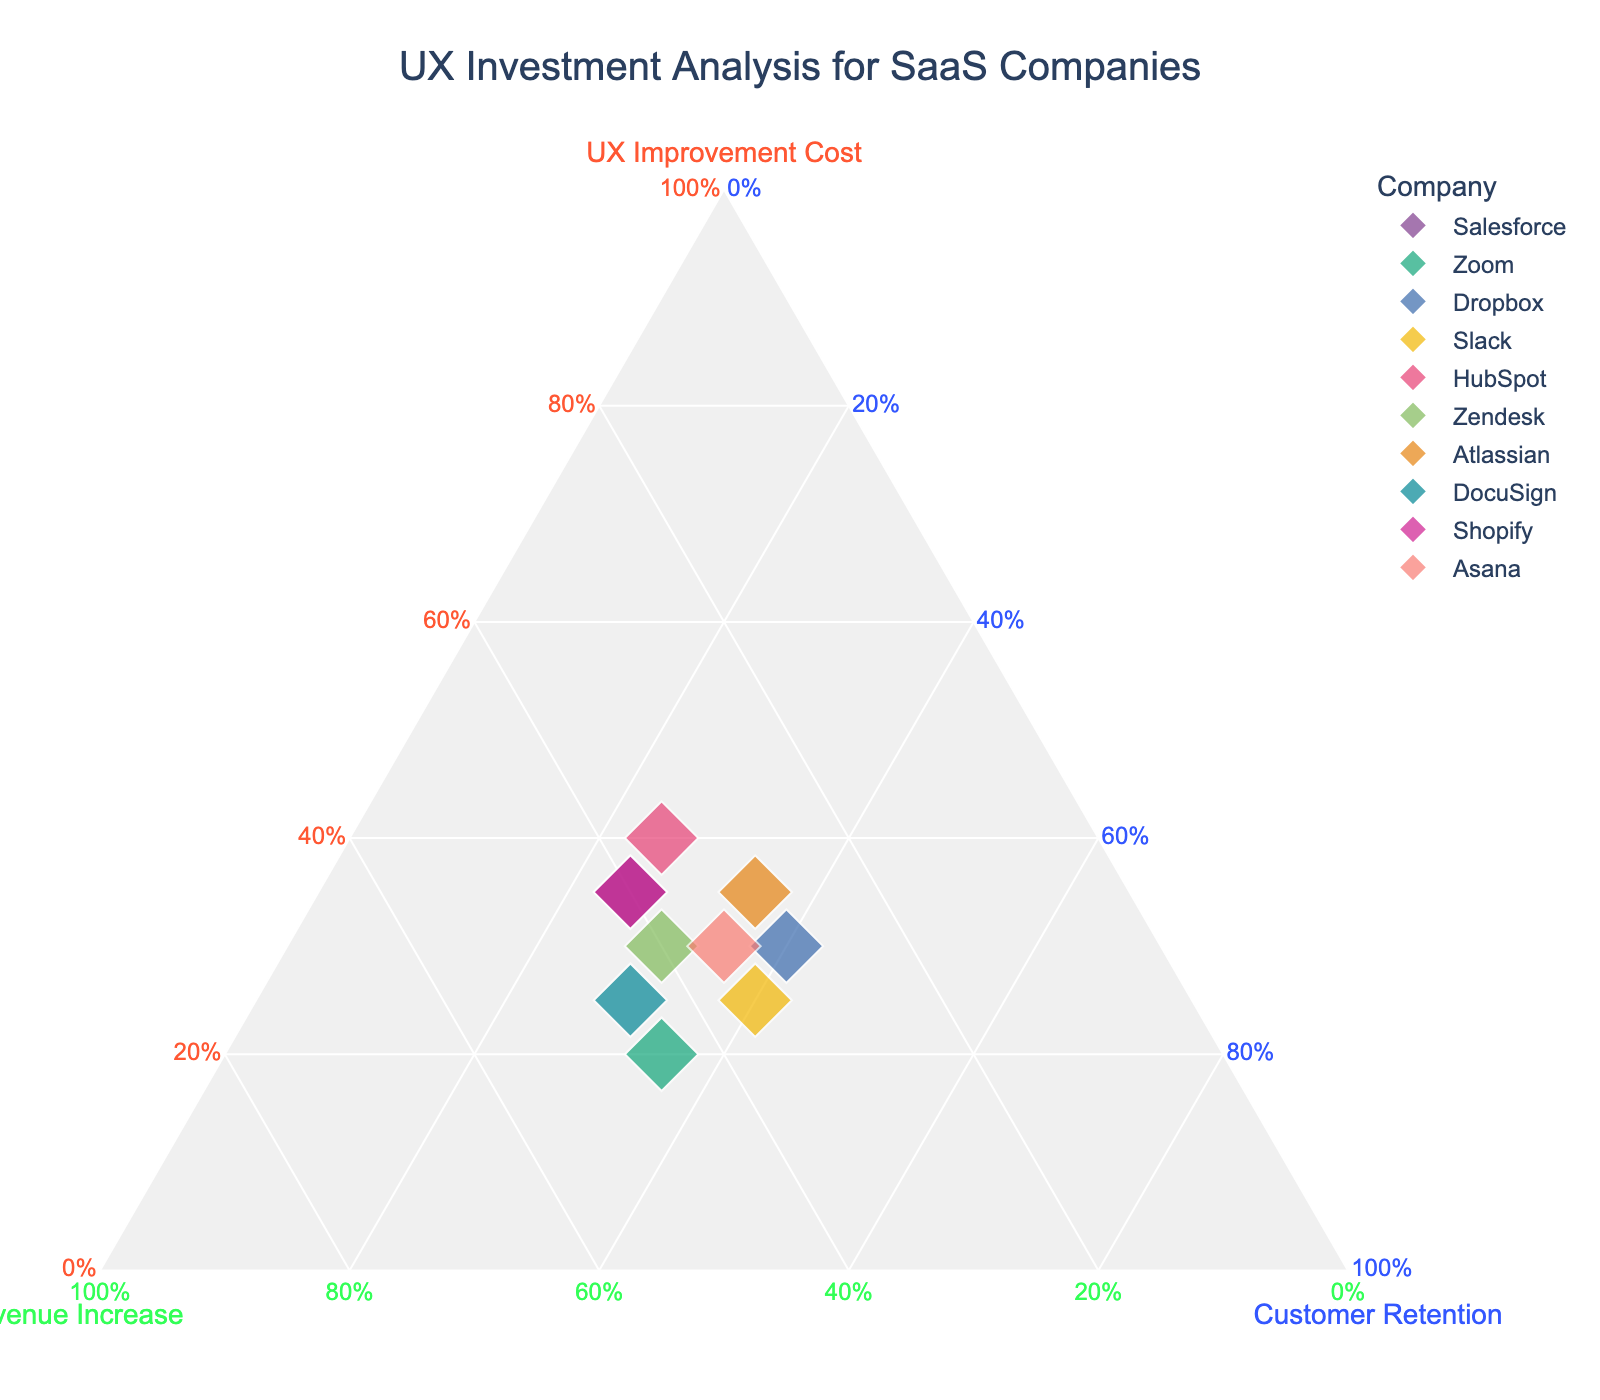What's the title of the figure? Look at the top of the figure where the title is generally placed. It reads "UX Investment Analysis for SaaS Companies".
Answer: "UX Investment Analysis for SaaS Companies" How many companies are plotted in the figure? The plot uses different colors for each company, and counting these unique colors will give the number of companies. There are 10 companies represented.
Answer: 10 Which company has the highest customer retention? Identify the point farthest along the "Customer Retention" axis, which is labeled as 40% or more. Dropbox and Slack both have customer retention values of 40%.
Answer: Dropbox and Slack What's the difference in customer retention between Salesforce and HubSpot? Both companies are plotted on the figure. Find their coordinates along the "Customer Retention" axis and calculate the difference. Salesforce has 25% and HubSpot has 25%, the difference is zero.
Answer: 0% Which companies have equal revenue increase percentages? Locate and compare the positions of the companies along the "Revenue Increase" axis. HubSpot and Zendesk both have revenue increases of 35%.
Answer: HubSpot and Zendesk What's the sum of UX improvement costs for Atlassian and Slack? Locate both companies' positions along the "UX Improvement Cost" axis and add their values: Atlassian (35%) + Slack (25%) = 60%.
Answer: 60% Do any companies have the same ratios for all three categories? Compare each company's position along all three axes. No companies have identical values for UX Improvement Cost, Revenue Increase, and Customer Retention.
Answer: No Which company requires the least investment in UX improvement? Find the company plotted closest to the origin point of the "UX Improvement Cost" axis; that's Zoom with a value of 20%.
Answer: Zoom Which company is primarily focused on revenue increase relative to UX costs and customer retention? Identify the company whose plot point is closest to the "Revenue Increase" axis and farthest from the other two axes. This is DocuSign with 45% revenue increase.
Answer: DocuSign 